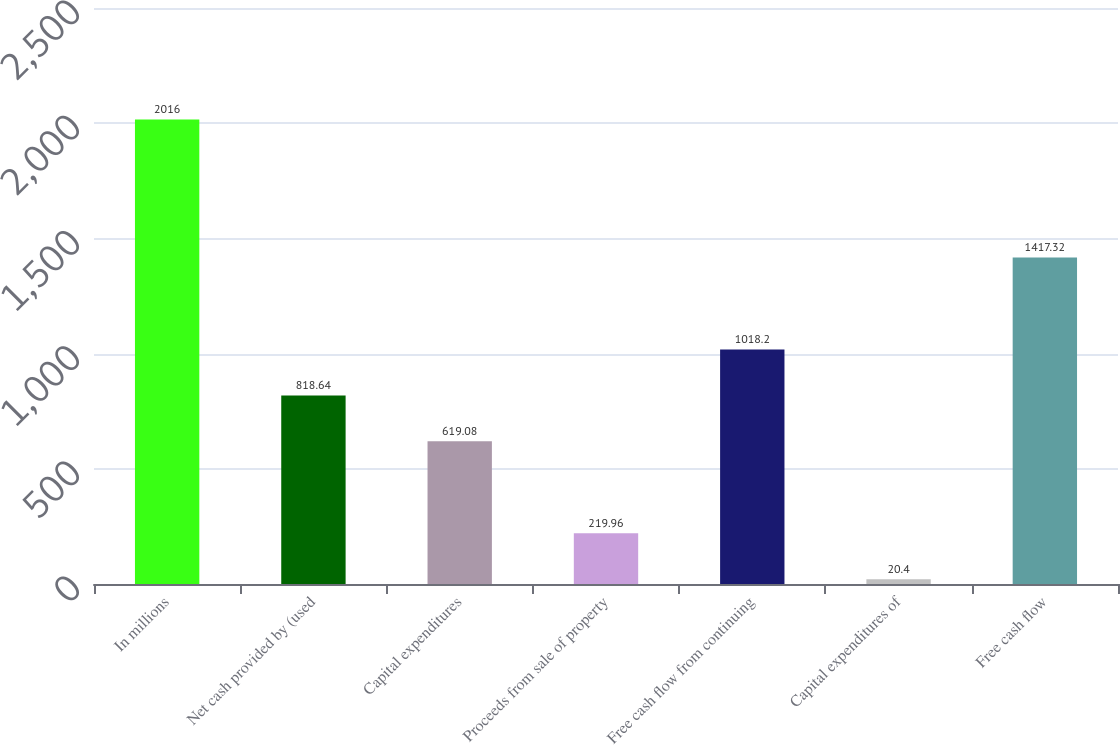<chart> <loc_0><loc_0><loc_500><loc_500><bar_chart><fcel>In millions<fcel>Net cash provided by (used<fcel>Capital expenditures<fcel>Proceeds from sale of property<fcel>Free cash flow from continuing<fcel>Capital expenditures of<fcel>Free cash flow<nl><fcel>2016<fcel>818.64<fcel>619.08<fcel>219.96<fcel>1018.2<fcel>20.4<fcel>1417.32<nl></chart> 